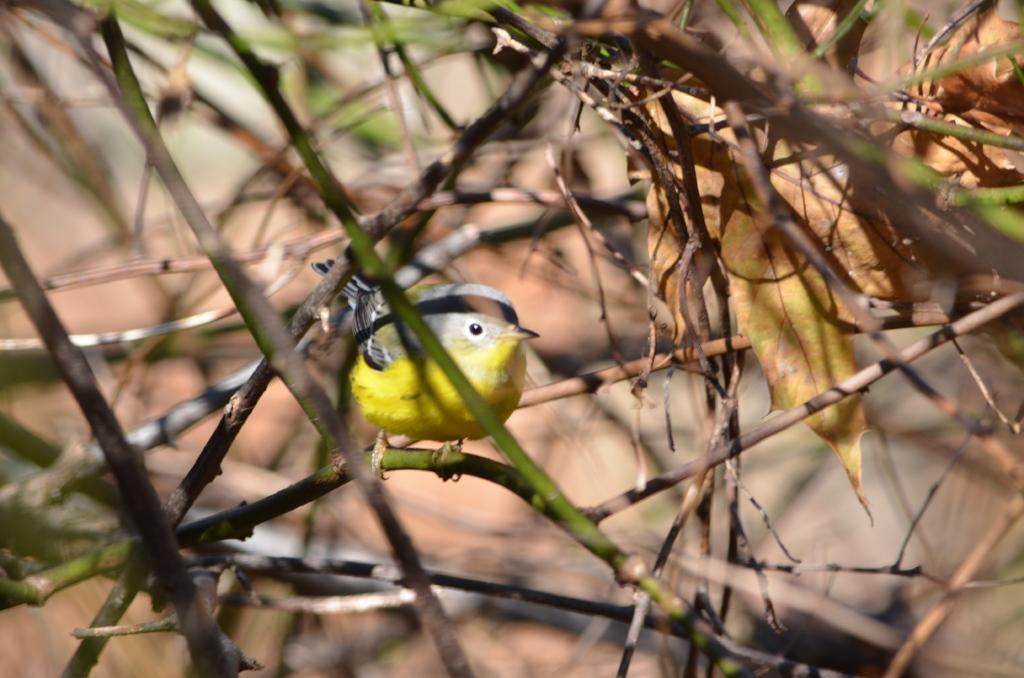Could you give a brief overview of what you see in this image? In this image, we can see some sticks and leaves. There is a bird in the middle of the image which is colored yellow. 